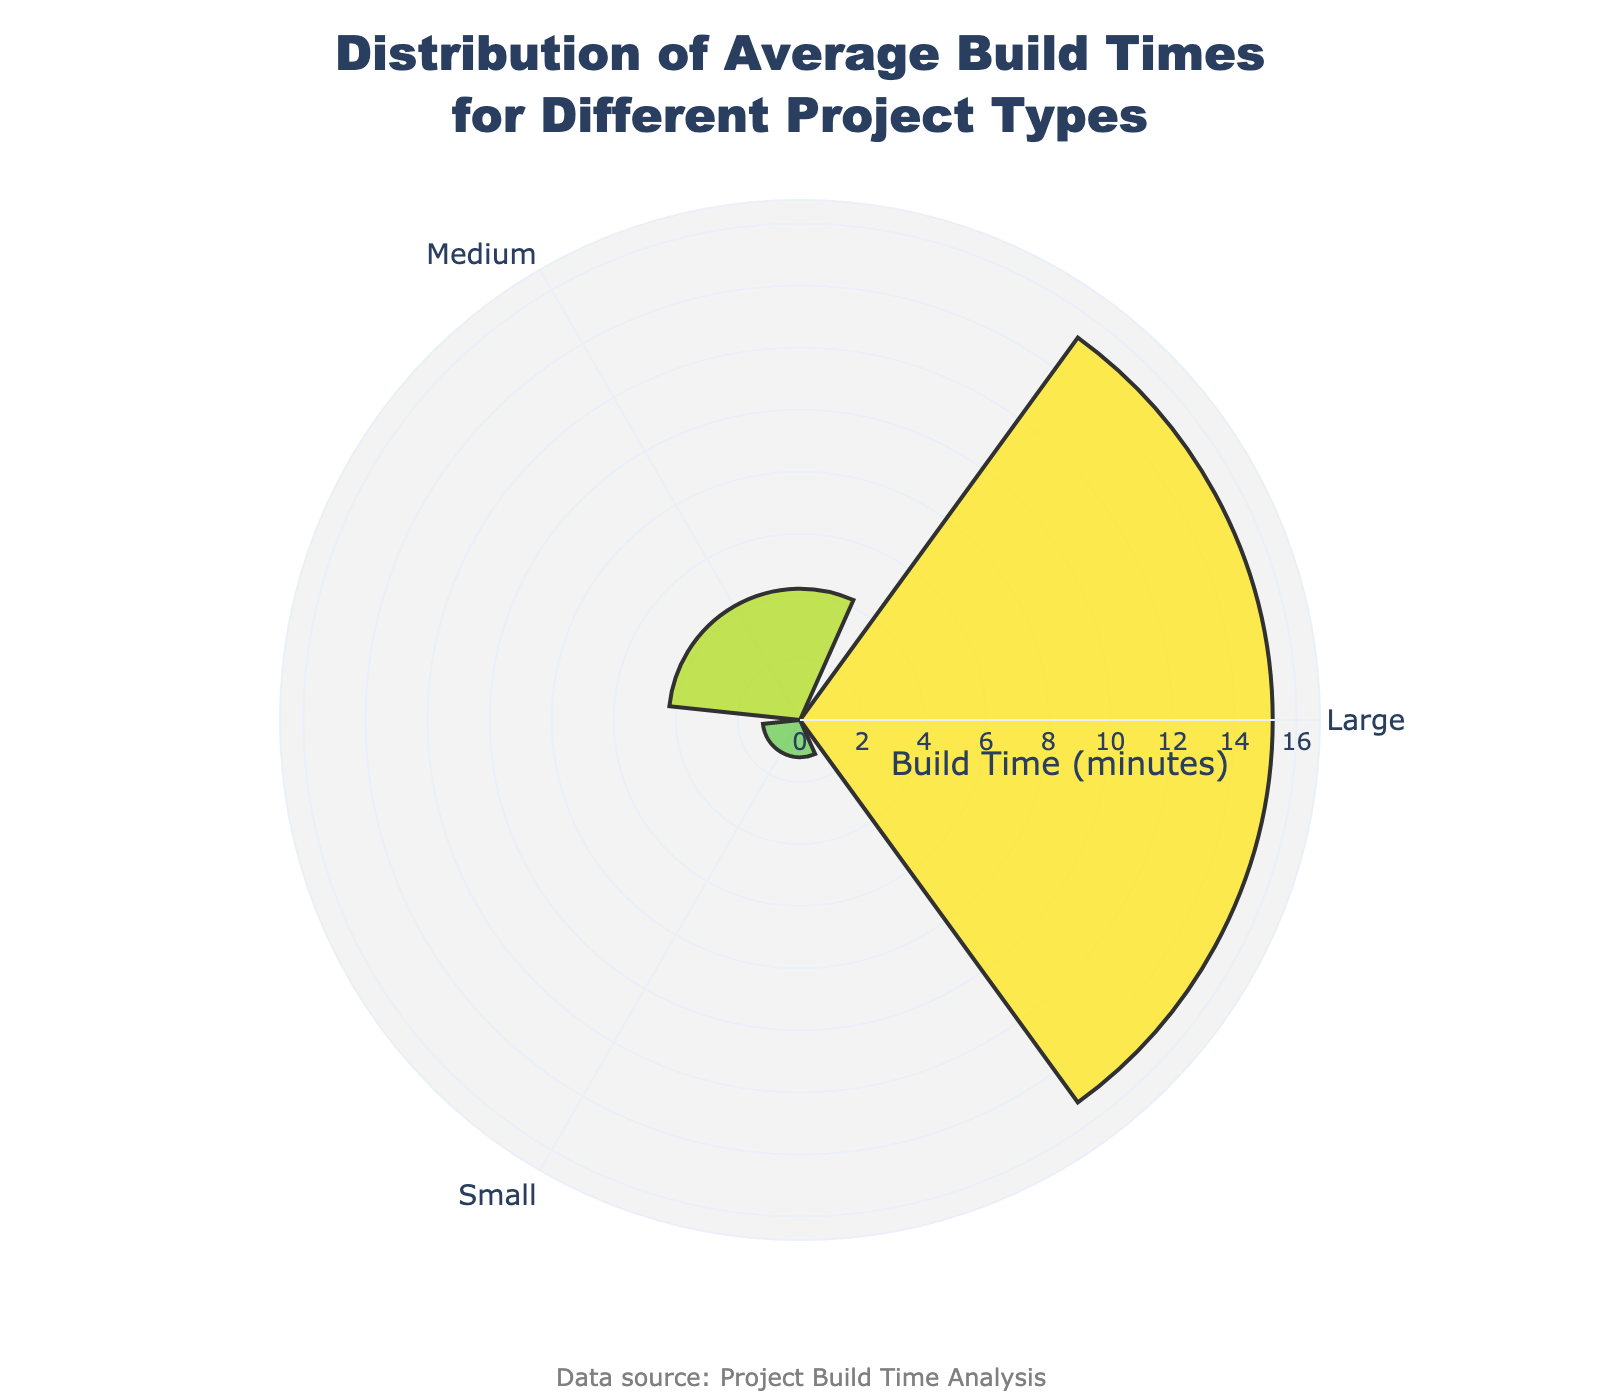Which Project Type has the highest average build time? The figure shows the average build times for different project types. By looking at the radial axis, you can see that the 'Large' Project Type has the highest value.
Answer: Large What is the average build time for 'Medium' projects? According to the hover information and radial distances of the bars, the 'Medium' Project Type has an average build time of approximately 4.23 minutes.
Answer: 4.23 minutes Compare the average build time of 'Small' projects with 'Large' projects. Which is larger and by how much? By observing the radial lengths, 'Large' projects have the highest average build time of around 15.23 minutes, whereas 'Small' projects have an average build time of around 1.2 minutes. The difference is 15.23 - 1.2 = 14.03 minutes.
Answer: Large, by 14.03 minutes What is the range of build times in the chart? The range can be determined by identifying the minimum and maximum values from the radial axis. The smallest build time is 1.2 minutes ('Small') and the largest is 15.23 minutes ('Large'). The range is 15.23 - 1.2 = 14.03 minutes.
Answer: 14.03 minutes Which Project Type has the lowest average build time? The figure shows the radial distances for each Project Type's average build time. 'Small' has the shortest radial length, indicating the lowest average build time.
Answer: Small Compare the average build times of the 'Small' and 'Medium' projects. How much more time does the 'Medium' Project Type require on average? From the radial lengths, 'Medium' projects have an average build time of about 4.23 minutes, whereas 'Small' projects average around 1.2 minutes. The additional time required for 'Medium' is 4.23 - 1.2 = 3.03 minutes.
Answer: 3.03 minutes How many distinct Project Types are shown in the chart? The chart has distinct bars for each Project Type, and there are three unique groups ('Small', 'Medium', 'Large').
Answer: Three What is the title of the chart? The title is located at the top of the chart and clearly reads "Distribution of Average Build Times for Different Project Types."
Answer: Distribution of Average Build Times for Different Project Types What type of data representation is used in this chart? This chart uses a rose chart (also known as a barpolar chart) to display the distribution of average build times by Project Type.
Answer: Rose Chart 